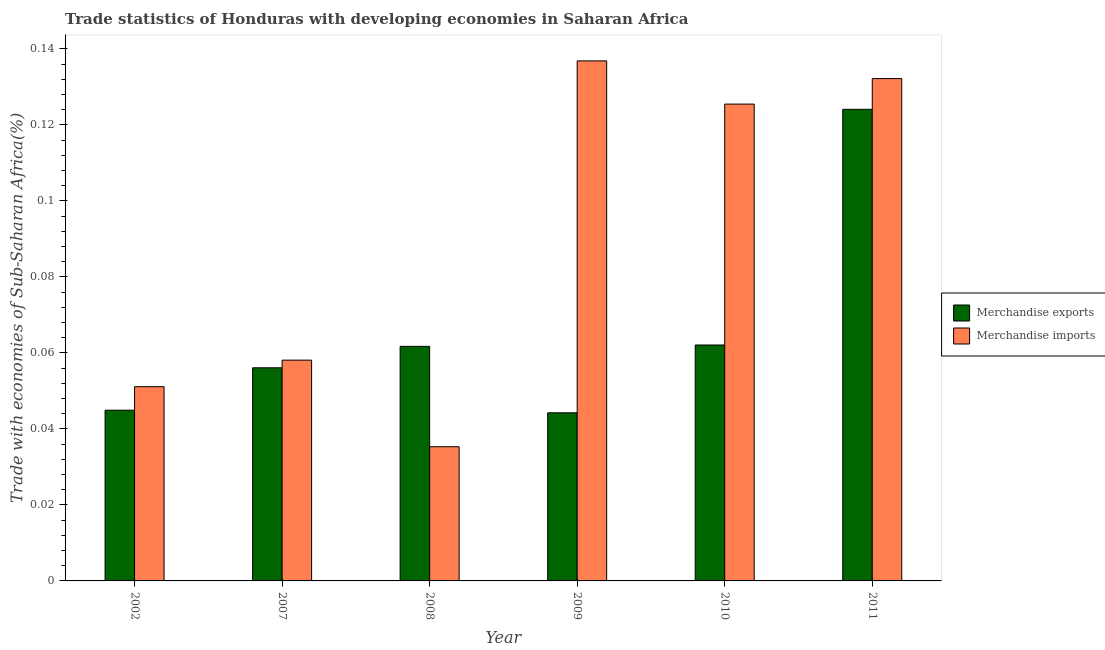Are the number of bars per tick equal to the number of legend labels?
Give a very brief answer. Yes. Are the number of bars on each tick of the X-axis equal?
Your answer should be very brief. Yes. How many bars are there on the 5th tick from the left?
Provide a short and direct response. 2. What is the label of the 4th group of bars from the left?
Your answer should be compact. 2009. In how many cases, is the number of bars for a given year not equal to the number of legend labels?
Your answer should be compact. 0. What is the merchandise exports in 2002?
Provide a short and direct response. 0.04. Across all years, what is the maximum merchandise imports?
Make the answer very short. 0.14. Across all years, what is the minimum merchandise imports?
Provide a short and direct response. 0.04. What is the total merchandise exports in the graph?
Your answer should be very brief. 0.39. What is the difference between the merchandise imports in 2010 and that in 2011?
Provide a succinct answer. -0.01. What is the difference between the merchandise imports in 2011 and the merchandise exports in 2008?
Offer a terse response. 0.1. What is the average merchandise imports per year?
Give a very brief answer. 0.09. In the year 2007, what is the difference between the merchandise exports and merchandise imports?
Provide a short and direct response. 0. In how many years, is the merchandise exports greater than 0.076 %?
Offer a terse response. 1. What is the ratio of the merchandise exports in 2007 to that in 2010?
Make the answer very short. 0.9. Is the merchandise exports in 2002 less than that in 2008?
Offer a terse response. Yes. Is the difference between the merchandise imports in 2002 and 2007 greater than the difference between the merchandise exports in 2002 and 2007?
Ensure brevity in your answer.  No. What is the difference between the highest and the second highest merchandise exports?
Keep it short and to the point. 0.06. What is the difference between the highest and the lowest merchandise exports?
Make the answer very short. 0.08. In how many years, is the merchandise imports greater than the average merchandise imports taken over all years?
Provide a succinct answer. 3. Is the sum of the merchandise imports in 2010 and 2011 greater than the maximum merchandise exports across all years?
Provide a succinct answer. Yes. What does the 2nd bar from the right in 2011 represents?
Make the answer very short. Merchandise exports. How many years are there in the graph?
Your answer should be very brief. 6. Are the values on the major ticks of Y-axis written in scientific E-notation?
Ensure brevity in your answer.  No. Does the graph contain any zero values?
Give a very brief answer. No. Where does the legend appear in the graph?
Make the answer very short. Center right. How are the legend labels stacked?
Your answer should be compact. Vertical. What is the title of the graph?
Provide a succinct answer. Trade statistics of Honduras with developing economies in Saharan Africa. What is the label or title of the Y-axis?
Provide a short and direct response. Trade with economies of Sub-Saharan Africa(%). What is the Trade with economies of Sub-Saharan Africa(%) in Merchandise exports in 2002?
Keep it short and to the point. 0.04. What is the Trade with economies of Sub-Saharan Africa(%) in Merchandise imports in 2002?
Make the answer very short. 0.05. What is the Trade with economies of Sub-Saharan Africa(%) in Merchandise exports in 2007?
Provide a succinct answer. 0.06. What is the Trade with economies of Sub-Saharan Africa(%) of Merchandise imports in 2007?
Provide a short and direct response. 0.06. What is the Trade with economies of Sub-Saharan Africa(%) in Merchandise exports in 2008?
Your answer should be very brief. 0.06. What is the Trade with economies of Sub-Saharan Africa(%) in Merchandise imports in 2008?
Make the answer very short. 0.04. What is the Trade with economies of Sub-Saharan Africa(%) of Merchandise exports in 2009?
Make the answer very short. 0.04. What is the Trade with economies of Sub-Saharan Africa(%) in Merchandise imports in 2009?
Your response must be concise. 0.14. What is the Trade with economies of Sub-Saharan Africa(%) of Merchandise exports in 2010?
Keep it short and to the point. 0.06. What is the Trade with economies of Sub-Saharan Africa(%) of Merchandise imports in 2010?
Offer a very short reply. 0.13. What is the Trade with economies of Sub-Saharan Africa(%) of Merchandise exports in 2011?
Your answer should be very brief. 0.12. What is the Trade with economies of Sub-Saharan Africa(%) of Merchandise imports in 2011?
Provide a short and direct response. 0.13. Across all years, what is the maximum Trade with economies of Sub-Saharan Africa(%) of Merchandise exports?
Give a very brief answer. 0.12. Across all years, what is the maximum Trade with economies of Sub-Saharan Africa(%) in Merchandise imports?
Ensure brevity in your answer.  0.14. Across all years, what is the minimum Trade with economies of Sub-Saharan Africa(%) of Merchandise exports?
Your answer should be very brief. 0.04. Across all years, what is the minimum Trade with economies of Sub-Saharan Africa(%) of Merchandise imports?
Your answer should be compact. 0.04. What is the total Trade with economies of Sub-Saharan Africa(%) of Merchandise exports in the graph?
Your response must be concise. 0.39. What is the total Trade with economies of Sub-Saharan Africa(%) in Merchandise imports in the graph?
Make the answer very short. 0.54. What is the difference between the Trade with economies of Sub-Saharan Africa(%) in Merchandise exports in 2002 and that in 2007?
Ensure brevity in your answer.  -0.01. What is the difference between the Trade with economies of Sub-Saharan Africa(%) in Merchandise imports in 2002 and that in 2007?
Your answer should be very brief. -0.01. What is the difference between the Trade with economies of Sub-Saharan Africa(%) in Merchandise exports in 2002 and that in 2008?
Provide a succinct answer. -0.02. What is the difference between the Trade with economies of Sub-Saharan Africa(%) of Merchandise imports in 2002 and that in 2008?
Offer a terse response. 0.02. What is the difference between the Trade with economies of Sub-Saharan Africa(%) in Merchandise exports in 2002 and that in 2009?
Make the answer very short. 0. What is the difference between the Trade with economies of Sub-Saharan Africa(%) in Merchandise imports in 2002 and that in 2009?
Your answer should be compact. -0.09. What is the difference between the Trade with economies of Sub-Saharan Africa(%) of Merchandise exports in 2002 and that in 2010?
Offer a terse response. -0.02. What is the difference between the Trade with economies of Sub-Saharan Africa(%) in Merchandise imports in 2002 and that in 2010?
Your answer should be compact. -0.07. What is the difference between the Trade with economies of Sub-Saharan Africa(%) in Merchandise exports in 2002 and that in 2011?
Make the answer very short. -0.08. What is the difference between the Trade with economies of Sub-Saharan Africa(%) of Merchandise imports in 2002 and that in 2011?
Provide a short and direct response. -0.08. What is the difference between the Trade with economies of Sub-Saharan Africa(%) of Merchandise exports in 2007 and that in 2008?
Give a very brief answer. -0.01. What is the difference between the Trade with economies of Sub-Saharan Africa(%) of Merchandise imports in 2007 and that in 2008?
Your answer should be very brief. 0.02. What is the difference between the Trade with economies of Sub-Saharan Africa(%) in Merchandise exports in 2007 and that in 2009?
Offer a terse response. 0.01. What is the difference between the Trade with economies of Sub-Saharan Africa(%) of Merchandise imports in 2007 and that in 2009?
Ensure brevity in your answer.  -0.08. What is the difference between the Trade with economies of Sub-Saharan Africa(%) in Merchandise exports in 2007 and that in 2010?
Ensure brevity in your answer.  -0.01. What is the difference between the Trade with economies of Sub-Saharan Africa(%) of Merchandise imports in 2007 and that in 2010?
Give a very brief answer. -0.07. What is the difference between the Trade with economies of Sub-Saharan Africa(%) in Merchandise exports in 2007 and that in 2011?
Provide a succinct answer. -0.07. What is the difference between the Trade with economies of Sub-Saharan Africa(%) in Merchandise imports in 2007 and that in 2011?
Provide a succinct answer. -0.07. What is the difference between the Trade with economies of Sub-Saharan Africa(%) in Merchandise exports in 2008 and that in 2009?
Your answer should be compact. 0.02. What is the difference between the Trade with economies of Sub-Saharan Africa(%) of Merchandise imports in 2008 and that in 2009?
Make the answer very short. -0.1. What is the difference between the Trade with economies of Sub-Saharan Africa(%) in Merchandise exports in 2008 and that in 2010?
Provide a short and direct response. -0. What is the difference between the Trade with economies of Sub-Saharan Africa(%) in Merchandise imports in 2008 and that in 2010?
Offer a very short reply. -0.09. What is the difference between the Trade with economies of Sub-Saharan Africa(%) of Merchandise exports in 2008 and that in 2011?
Give a very brief answer. -0.06. What is the difference between the Trade with economies of Sub-Saharan Africa(%) in Merchandise imports in 2008 and that in 2011?
Your answer should be very brief. -0.1. What is the difference between the Trade with economies of Sub-Saharan Africa(%) in Merchandise exports in 2009 and that in 2010?
Make the answer very short. -0.02. What is the difference between the Trade with economies of Sub-Saharan Africa(%) of Merchandise imports in 2009 and that in 2010?
Your answer should be compact. 0.01. What is the difference between the Trade with economies of Sub-Saharan Africa(%) of Merchandise exports in 2009 and that in 2011?
Offer a very short reply. -0.08. What is the difference between the Trade with economies of Sub-Saharan Africa(%) in Merchandise imports in 2009 and that in 2011?
Make the answer very short. 0. What is the difference between the Trade with economies of Sub-Saharan Africa(%) in Merchandise exports in 2010 and that in 2011?
Give a very brief answer. -0.06. What is the difference between the Trade with economies of Sub-Saharan Africa(%) of Merchandise imports in 2010 and that in 2011?
Your response must be concise. -0.01. What is the difference between the Trade with economies of Sub-Saharan Africa(%) in Merchandise exports in 2002 and the Trade with economies of Sub-Saharan Africa(%) in Merchandise imports in 2007?
Your answer should be very brief. -0.01. What is the difference between the Trade with economies of Sub-Saharan Africa(%) of Merchandise exports in 2002 and the Trade with economies of Sub-Saharan Africa(%) of Merchandise imports in 2008?
Give a very brief answer. 0.01. What is the difference between the Trade with economies of Sub-Saharan Africa(%) of Merchandise exports in 2002 and the Trade with economies of Sub-Saharan Africa(%) of Merchandise imports in 2009?
Provide a succinct answer. -0.09. What is the difference between the Trade with economies of Sub-Saharan Africa(%) in Merchandise exports in 2002 and the Trade with economies of Sub-Saharan Africa(%) in Merchandise imports in 2010?
Offer a terse response. -0.08. What is the difference between the Trade with economies of Sub-Saharan Africa(%) in Merchandise exports in 2002 and the Trade with economies of Sub-Saharan Africa(%) in Merchandise imports in 2011?
Your answer should be compact. -0.09. What is the difference between the Trade with economies of Sub-Saharan Africa(%) in Merchandise exports in 2007 and the Trade with economies of Sub-Saharan Africa(%) in Merchandise imports in 2008?
Your response must be concise. 0.02. What is the difference between the Trade with economies of Sub-Saharan Africa(%) of Merchandise exports in 2007 and the Trade with economies of Sub-Saharan Africa(%) of Merchandise imports in 2009?
Provide a succinct answer. -0.08. What is the difference between the Trade with economies of Sub-Saharan Africa(%) in Merchandise exports in 2007 and the Trade with economies of Sub-Saharan Africa(%) in Merchandise imports in 2010?
Give a very brief answer. -0.07. What is the difference between the Trade with economies of Sub-Saharan Africa(%) in Merchandise exports in 2007 and the Trade with economies of Sub-Saharan Africa(%) in Merchandise imports in 2011?
Offer a terse response. -0.08. What is the difference between the Trade with economies of Sub-Saharan Africa(%) in Merchandise exports in 2008 and the Trade with economies of Sub-Saharan Africa(%) in Merchandise imports in 2009?
Your response must be concise. -0.08. What is the difference between the Trade with economies of Sub-Saharan Africa(%) in Merchandise exports in 2008 and the Trade with economies of Sub-Saharan Africa(%) in Merchandise imports in 2010?
Your response must be concise. -0.06. What is the difference between the Trade with economies of Sub-Saharan Africa(%) of Merchandise exports in 2008 and the Trade with economies of Sub-Saharan Africa(%) of Merchandise imports in 2011?
Make the answer very short. -0.07. What is the difference between the Trade with economies of Sub-Saharan Africa(%) of Merchandise exports in 2009 and the Trade with economies of Sub-Saharan Africa(%) of Merchandise imports in 2010?
Your response must be concise. -0.08. What is the difference between the Trade with economies of Sub-Saharan Africa(%) of Merchandise exports in 2009 and the Trade with economies of Sub-Saharan Africa(%) of Merchandise imports in 2011?
Your response must be concise. -0.09. What is the difference between the Trade with economies of Sub-Saharan Africa(%) of Merchandise exports in 2010 and the Trade with economies of Sub-Saharan Africa(%) of Merchandise imports in 2011?
Offer a very short reply. -0.07. What is the average Trade with economies of Sub-Saharan Africa(%) in Merchandise exports per year?
Offer a very short reply. 0.07. What is the average Trade with economies of Sub-Saharan Africa(%) in Merchandise imports per year?
Offer a terse response. 0.09. In the year 2002, what is the difference between the Trade with economies of Sub-Saharan Africa(%) of Merchandise exports and Trade with economies of Sub-Saharan Africa(%) of Merchandise imports?
Offer a terse response. -0.01. In the year 2007, what is the difference between the Trade with economies of Sub-Saharan Africa(%) in Merchandise exports and Trade with economies of Sub-Saharan Africa(%) in Merchandise imports?
Make the answer very short. -0. In the year 2008, what is the difference between the Trade with economies of Sub-Saharan Africa(%) in Merchandise exports and Trade with economies of Sub-Saharan Africa(%) in Merchandise imports?
Provide a succinct answer. 0.03. In the year 2009, what is the difference between the Trade with economies of Sub-Saharan Africa(%) in Merchandise exports and Trade with economies of Sub-Saharan Africa(%) in Merchandise imports?
Offer a terse response. -0.09. In the year 2010, what is the difference between the Trade with economies of Sub-Saharan Africa(%) in Merchandise exports and Trade with economies of Sub-Saharan Africa(%) in Merchandise imports?
Offer a terse response. -0.06. In the year 2011, what is the difference between the Trade with economies of Sub-Saharan Africa(%) of Merchandise exports and Trade with economies of Sub-Saharan Africa(%) of Merchandise imports?
Give a very brief answer. -0.01. What is the ratio of the Trade with economies of Sub-Saharan Africa(%) of Merchandise exports in 2002 to that in 2007?
Your response must be concise. 0.8. What is the ratio of the Trade with economies of Sub-Saharan Africa(%) in Merchandise imports in 2002 to that in 2007?
Offer a very short reply. 0.88. What is the ratio of the Trade with economies of Sub-Saharan Africa(%) of Merchandise exports in 2002 to that in 2008?
Ensure brevity in your answer.  0.73. What is the ratio of the Trade with economies of Sub-Saharan Africa(%) in Merchandise imports in 2002 to that in 2008?
Your answer should be compact. 1.45. What is the ratio of the Trade with economies of Sub-Saharan Africa(%) in Merchandise exports in 2002 to that in 2009?
Provide a short and direct response. 1.02. What is the ratio of the Trade with economies of Sub-Saharan Africa(%) of Merchandise imports in 2002 to that in 2009?
Your answer should be very brief. 0.37. What is the ratio of the Trade with economies of Sub-Saharan Africa(%) in Merchandise exports in 2002 to that in 2010?
Provide a short and direct response. 0.72. What is the ratio of the Trade with economies of Sub-Saharan Africa(%) in Merchandise imports in 2002 to that in 2010?
Your answer should be compact. 0.41. What is the ratio of the Trade with economies of Sub-Saharan Africa(%) in Merchandise exports in 2002 to that in 2011?
Make the answer very short. 0.36. What is the ratio of the Trade with economies of Sub-Saharan Africa(%) in Merchandise imports in 2002 to that in 2011?
Offer a very short reply. 0.39. What is the ratio of the Trade with economies of Sub-Saharan Africa(%) in Merchandise exports in 2007 to that in 2008?
Provide a short and direct response. 0.91. What is the ratio of the Trade with economies of Sub-Saharan Africa(%) in Merchandise imports in 2007 to that in 2008?
Your answer should be very brief. 1.65. What is the ratio of the Trade with economies of Sub-Saharan Africa(%) of Merchandise exports in 2007 to that in 2009?
Make the answer very short. 1.27. What is the ratio of the Trade with economies of Sub-Saharan Africa(%) in Merchandise imports in 2007 to that in 2009?
Provide a succinct answer. 0.42. What is the ratio of the Trade with economies of Sub-Saharan Africa(%) of Merchandise exports in 2007 to that in 2010?
Offer a terse response. 0.9. What is the ratio of the Trade with economies of Sub-Saharan Africa(%) of Merchandise imports in 2007 to that in 2010?
Provide a short and direct response. 0.46. What is the ratio of the Trade with economies of Sub-Saharan Africa(%) in Merchandise exports in 2007 to that in 2011?
Ensure brevity in your answer.  0.45. What is the ratio of the Trade with economies of Sub-Saharan Africa(%) in Merchandise imports in 2007 to that in 2011?
Ensure brevity in your answer.  0.44. What is the ratio of the Trade with economies of Sub-Saharan Africa(%) of Merchandise exports in 2008 to that in 2009?
Ensure brevity in your answer.  1.4. What is the ratio of the Trade with economies of Sub-Saharan Africa(%) of Merchandise imports in 2008 to that in 2009?
Provide a short and direct response. 0.26. What is the ratio of the Trade with economies of Sub-Saharan Africa(%) in Merchandise exports in 2008 to that in 2010?
Your response must be concise. 0.99. What is the ratio of the Trade with economies of Sub-Saharan Africa(%) in Merchandise imports in 2008 to that in 2010?
Your response must be concise. 0.28. What is the ratio of the Trade with economies of Sub-Saharan Africa(%) in Merchandise exports in 2008 to that in 2011?
Offer a very short reply. 0.5. What is the ratio of the Trade with economies of Sub-Saharan Africa(%) of Merchandise imports in 2008 to that in 2011?
Ensure brevity in your answer.  0.27. What is the ratio of the Trade with economies of Sub-Saharan Africa(%) in Merchandise exports in 2009 to that in 2010?
Ensure brevity in your answer.  0.71. What is the ratio of the Trade with economies of Sub-Saharan Africa(%) in Merchandise imports in 2009 to that in 2010?
Keep it short and to the point. 1.09. What is the ratio of the Trade with economies of Sub-Saharan Africa(%) of Merchandise exports in 2009 to that in 2011?
Provide a succinct answer. 0.36. What is the ratio of the Trade with economies of Sub-Saharan Africa(%) in Merchandise imports in 2009 to that in 2011?
Make the answer very short. 1.04. What is the ratio of the Trade with economies of Sub-Saharan Africa(%) in Merchandise exports in 2010 to that in 2011?
Your answer should be very brief. 0.5. What is the ratio of the Trade with economies of Sub-Saharan Africa(%) in Merchandise imports in 2010 to that in 2011?
Your response must be concise. 0.95. What is the difference between the highest and the second highest Trade with economies of Sub-Saharan Africa(%) of Merchandise exports?
Your response must be concise. 0.06. What is the difference between the highest and the second highest Trade with economies of Sub-Saharan Africa(%) of Merchandise imports?
Give a very brief answer. 0. What is the difference between the highest and the lowest Trade with economies of Sub-Saharan Africa(%) in Merchandise exports?
Ensure brevity in your answer.  0.08. What is the difference between the highest and the lowest Trade with economies of Sub-Saharan Africa(%) of Merchandise imports?
Your response must be concise. 0.1. 